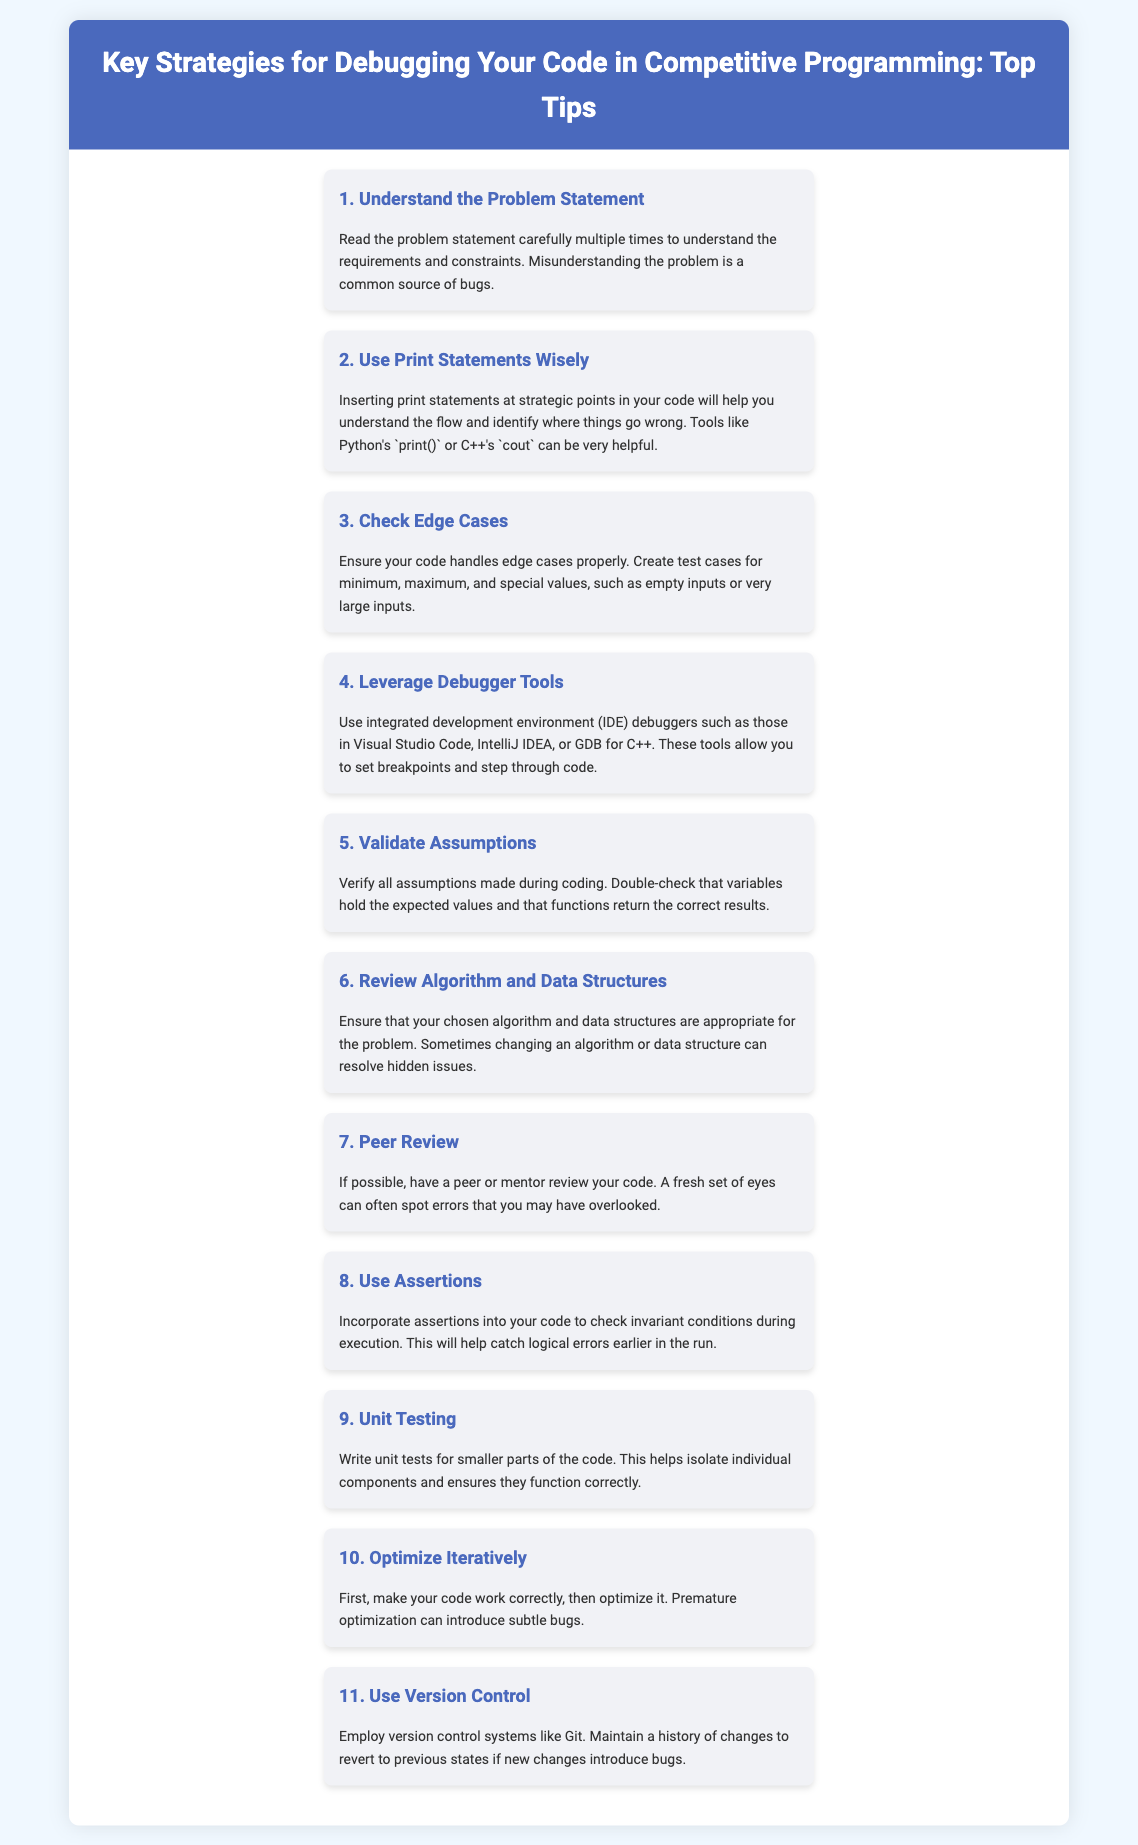what is the title of the document? The title of the document is presented in the header section and describes the content about debugging strategies.
Answer: Key Strategies for Debugging Your Code in Competitive Programming: Top Tips how many strategies are listed in the document? The document contains a list of strategies, each outlined with a heading and accompanying description.
Answer: 11 which strategy focuses on using assertions? The document includes a specific strategy dedicated to using assertions to catch errors.
Answer: Use Assertions what is the primary purpose of peer review in debugging? The document mentions that peer review helps identify overlooked errors by providing an external perspective.
Answer: Spot errors which software tools are mentioned for debugging? The document refers to various integrated development environment tools appropriate for debugging tasks.
Answer: Visual Studio Code, IntelliJ IDEA, GDB what should come before optimizing the code? The document advises making the code function correctly before any optimization efforts are made.
Answer: Make your code work correctly name one method to validate assumptions in coding. The document suggests that verifying the values of variables is a way to ensure assumptions are correct.
Answer: Double-check variables how should unit testing be conducted according to the document? The document emphasizes writing unit tests for smaller parts of the code to ensure individual components function correctly.
Answer: For smaller parts of the code what is emphasized regarding the handling of edge cases? The document stresses the importance of creating test cases to ensure the code operates properly under different scenarios.
Answer: Create test cases what is a potential benefit of using version control systems? The document highlights maintaining a history of changes to facilitate reverting to previous states as a potential advantage.
Answer: Revert to previous states 